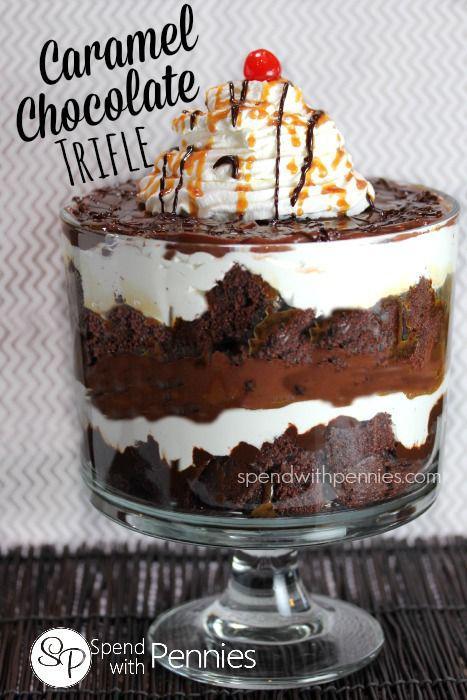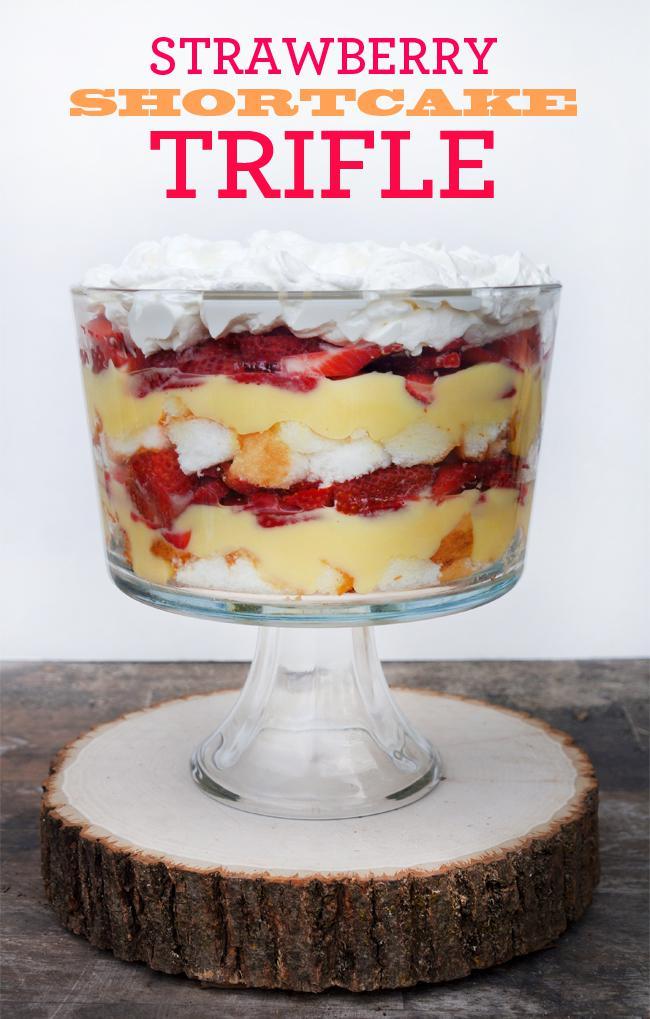The first image is the image on the left, the second image is the image on the right. For the images displayed, is the sentence "Exactly two large trifle desserts in clear footed bowls are shown, one made with chocolate layers and one made with strawberries." factually correct? Answer yes or no. Yes. The first image is the image on the left, the second image is the image on the right. Assess this claim about the two images: "An image shows a layered dessert in a footed glass sitting directly on wood furniture.". Correct or not? Answer yes or no. No. 